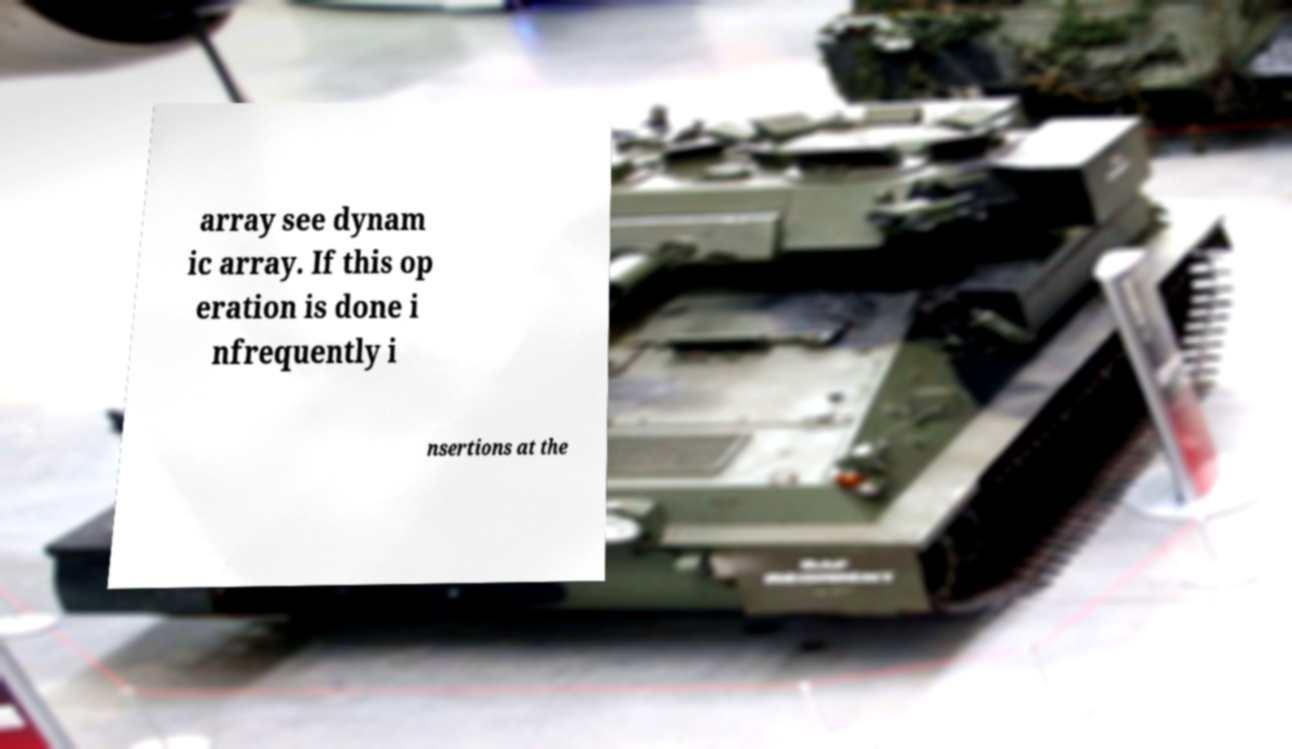I need the written content from this picture converted into text. Can you do that? array see dynam ic array. If this op eration is done i nfrequently i nsertions at the 